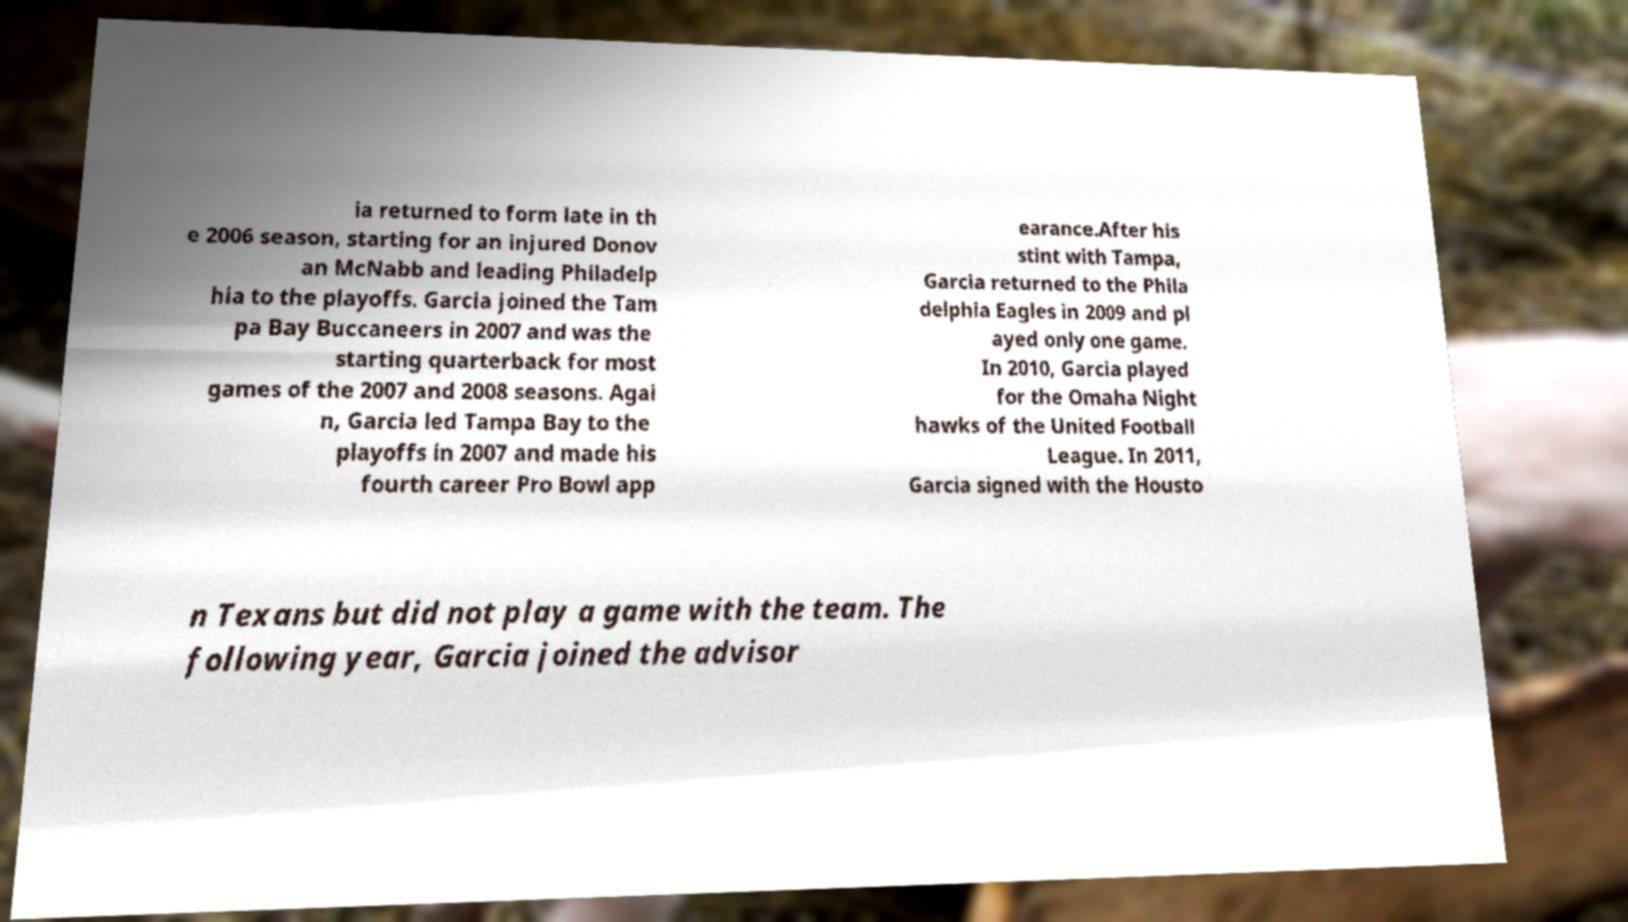Can you accurately transcribe the text from the provided image for me? ia returned to form late in th e 2006 season, starting for an injured Donov an McNabb and leading Philadelp hia to the playoffs. Garcia joined the Tam pa Bay Buccaneers in 2007 and was the starting quarterback for most games of the 2007 and 2008 seasons. Agai n, Garcia led Tampa Bay to the playoffs in 2007 and made his fourth career Pro Bowl app earance.After his stint with Tampa, Garcia returned to the Phila delphia Eagles in 2009 and pl ayed only one game. In 2010, Garcia played for the Omaha Night hawks of the United Football League. In 2011, Garcia signed with the Housto n Texans but did not play a game with the team. The following year, Garcia joined the advisor 